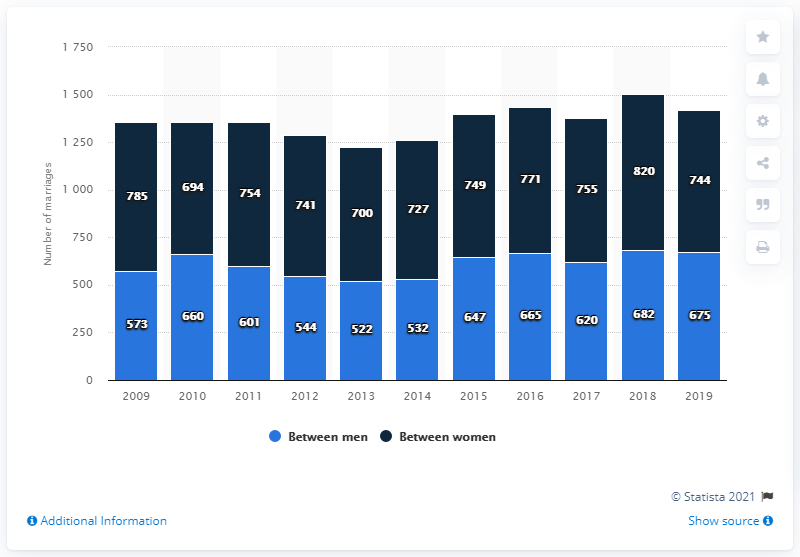What was the highest number of marriages recorded and in which year? The highest recorded number of marriages is in the year 2018 with 820 marriages between women and 682 marriages between men, totaling 1502 marriages for that year. Has there been a year where marriages between women have surpassed those between men? Yes, according to the chart, marriages between women have surpassed those between men every year from 2009 to 2019. 